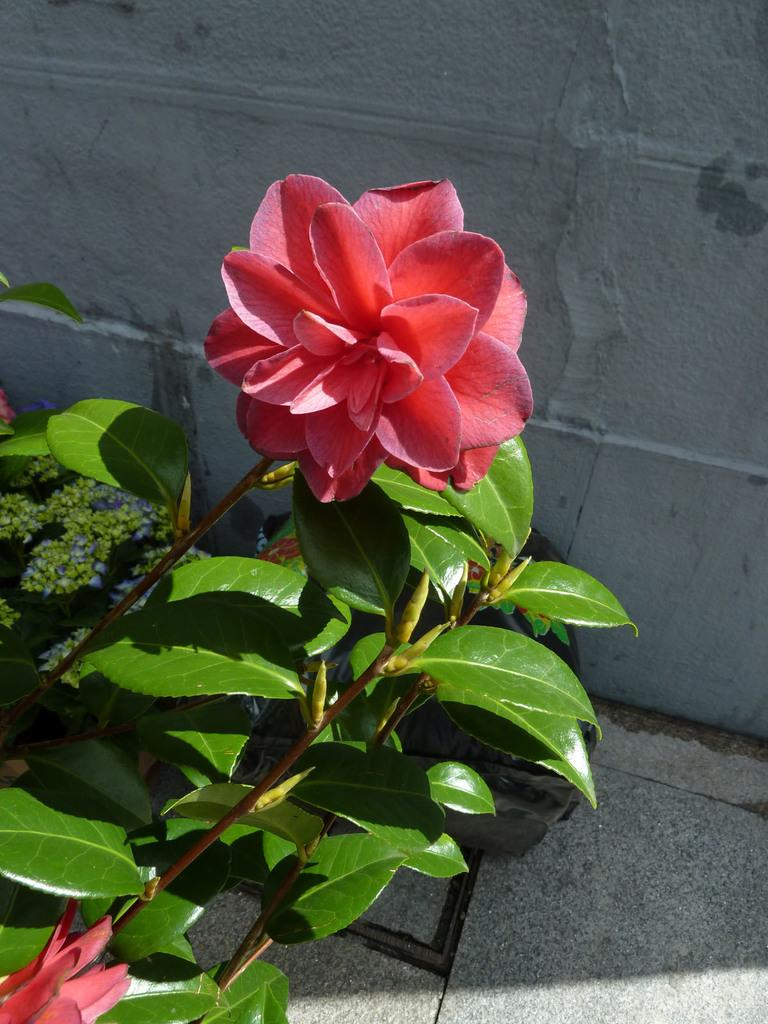What type of living organisms can be seen in the image? Flowers, buds, and plants are visible in the image. What is the stage of development for some of the flowers in the image? There are buds in the image, which are flowers in the early stages of development. What is visible in the background of the image? There is a wall in the background of the image. What type of company is celebrating a birthday in the image? There is no company or birthday celebration present in the image; it features flowers, buds, and plants. What type of sport is being played in the image? There is no sport or volleyball game present in the image; it features flowers, buds, and plants. 